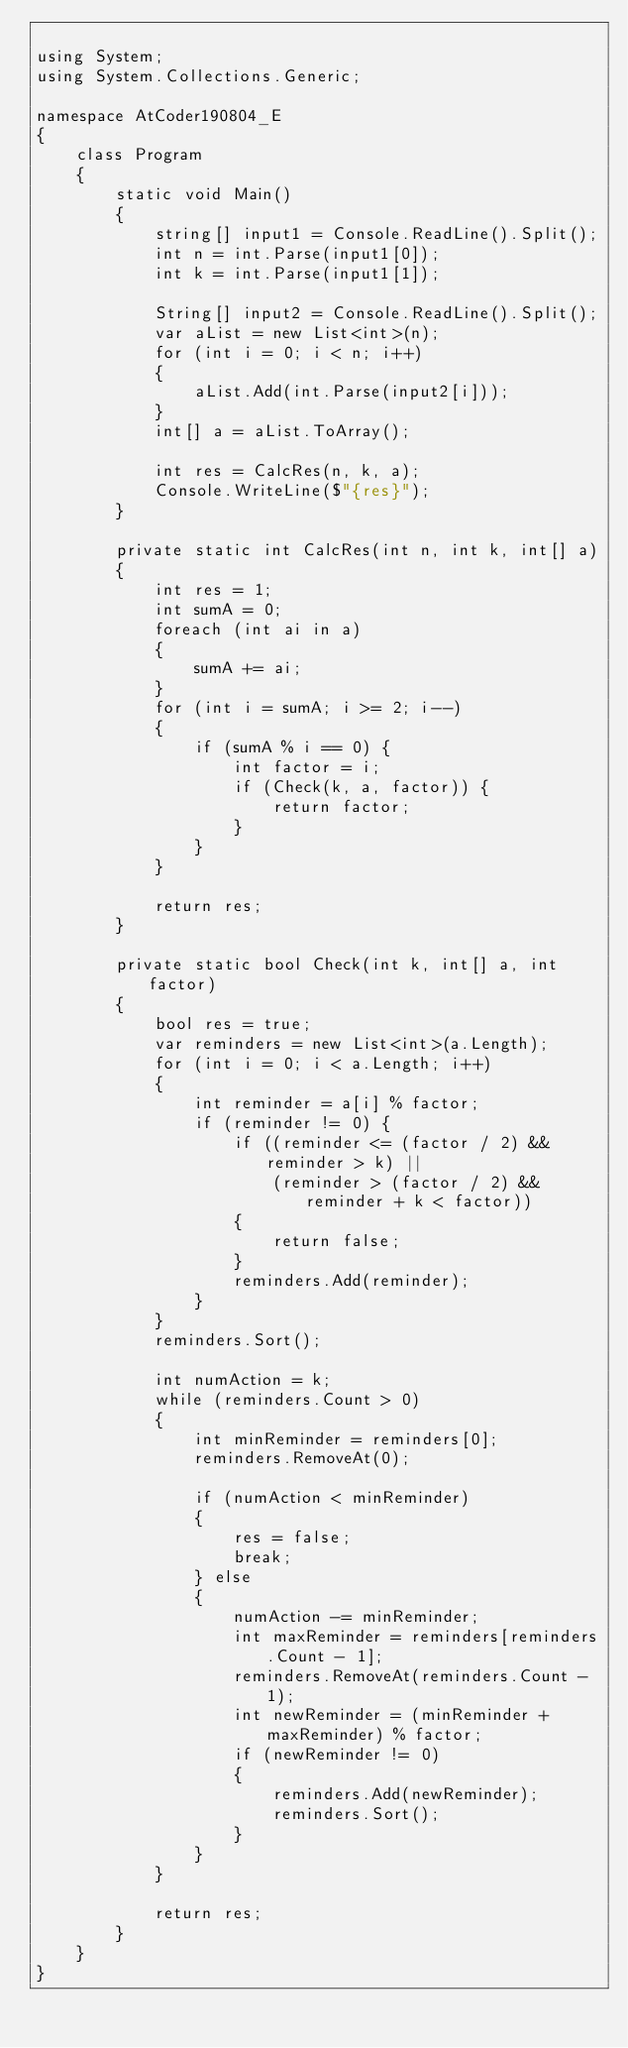Convert code to text. <code><loc_0><loc_0><loc_500><loc_500><_C#_>
using System;
using System.Collections.Generic;

namespace AtCoder190804_E
{
    class Program
    {
        static void Main()
        {
            string[] input1 = Console.ReadLine().Split();
            int n = int.Parse(input1[0]);
            int k = int.Parse(input1[1]);

            String[] input2 = Console.ReadLine().Split();
            var aList = new List<int>(n);
            for (int i = 0; i < n; i++)
            {
                aList.Add(int.Parse(input2[i]));
            }
            int[] a = aList.ToArray();

            int res = CalcRes(n, k, a);
            Console.WriteLine($"{res}");
        }

        private static int CalcRes(int n, int k, int[] a)
        {
            int res = 1;
            int sumA = 0;
            foreach (int ai in a)
            {
                sumA += ai;
            }
            for (int i = sumA; i >= 2; i--)
            {
                if (sumA % i == 0) {
                    int factor = i;
                    if (Check(k, a, factor)) {
                        return factor;
                    }
                }
            }

            return res;
        }

        private static bool Check(int k, int[] a, int factor)
        {
            bool res = true;
            var reminders = new List<int>(a.Length);
            for (int i = 0; i < a.Length; i++)
            {
                int reminder = a[i] % factor;
                if (reminder != 0) {
                    if ((reminder <= (factor / 2) && reminder > k) ||
                        (reminder > (factor / 2) && reminder + k < factor))
                    {
                        return false;
                    }
                    reminders.Add(reminder);
                }
            }
            reminders.Sort();

            int numAction = k;
            while (reminders.Count > 0)
            {
                int minReminder = reminders[0];
                reminders.RemoveAt(0);

                if (numAction < minReminder)
                {
                    res = false;
                    break;
                } else
                {
                    numAction -= minReminder;
                    int maxReminder = reminders[reminders.Count - 1];
                    reminders.RemoveAt(reminders.Count - 1);
                    int newReminder = (minReminder + maxReminder) % factor;
                    if (newReminder != 0)
                    {
                        reminders.Add(newReminder);
                        reminders.Sort();
                    }
                }
            }

            return res;
        }
    }
}
</code> 